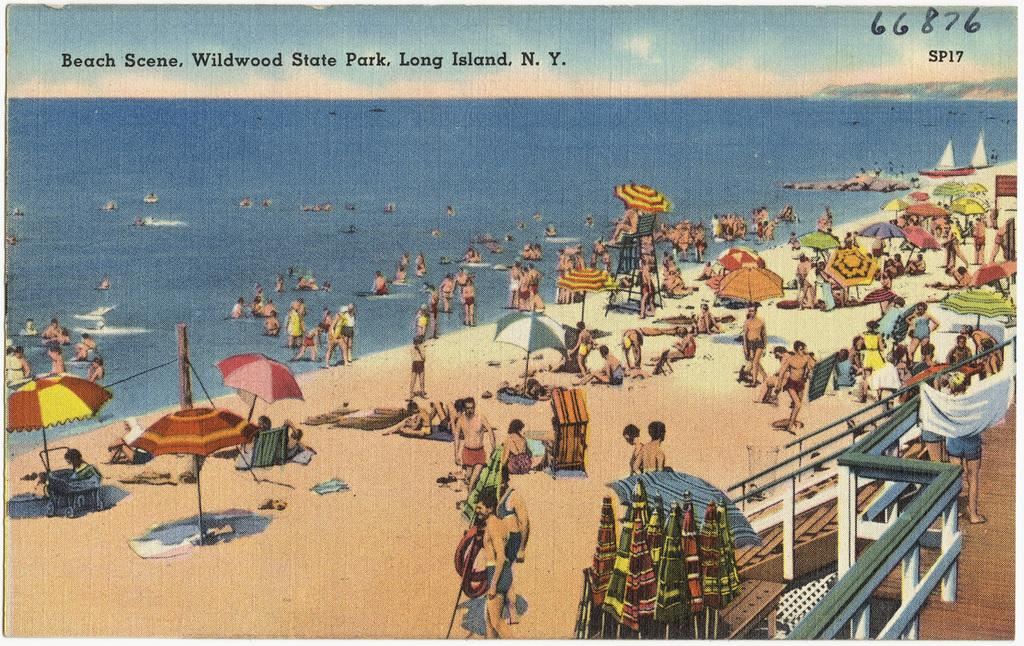<image>
Render a clear and concise summary of the photo. A painting of an ocean beach packed with people in Long Island, N. Y. 